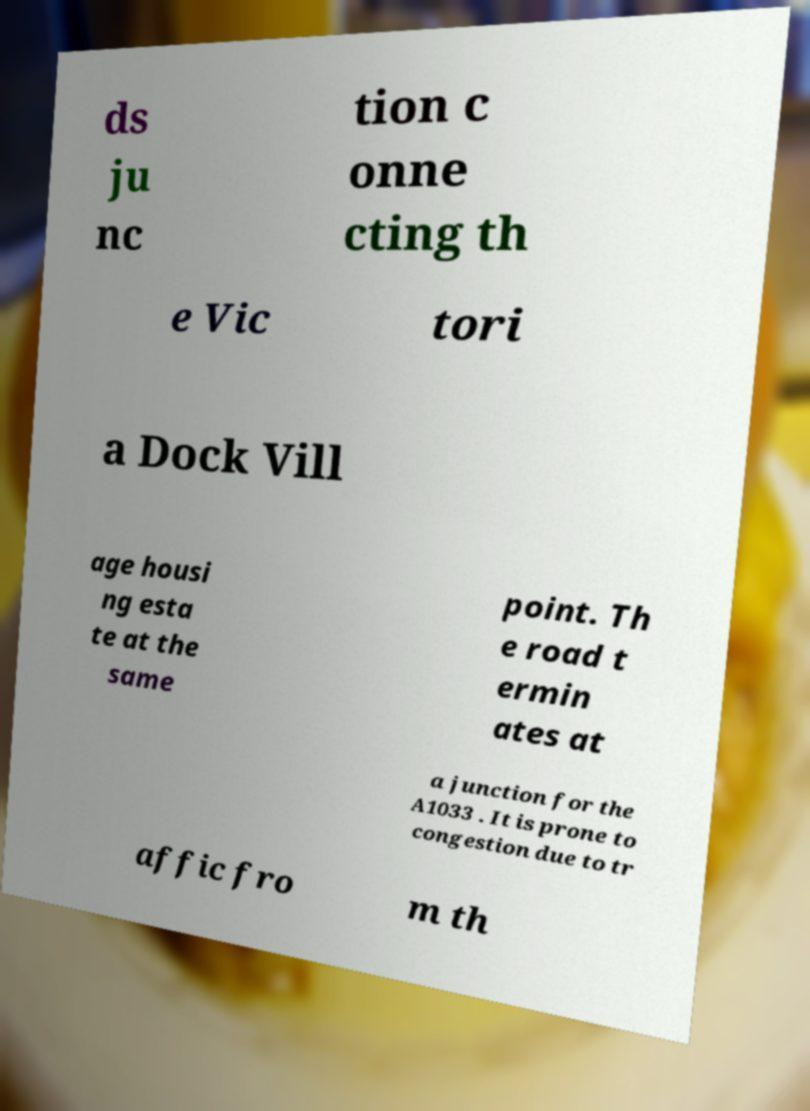There's text embedded in this image that I need extracted. Can you transcribe it verbatim? ds ju nc tion c onne cting th e Vic tori a Dock Vill age housi ng esta te at the same point. Th e road t ermin ates at a junction for the A1033 . It is prone to congestion due to tr affic fro m th 